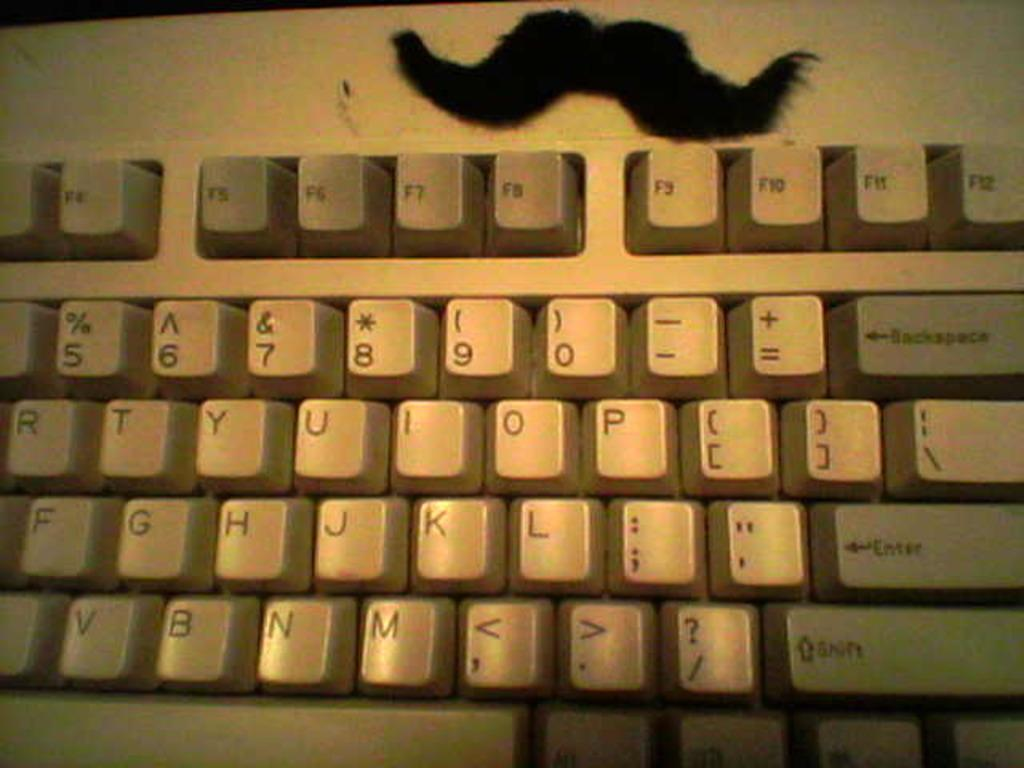Provide a one-sentence caption for the provided image. A white computer keyboard with shift,enter and backspace keys. 